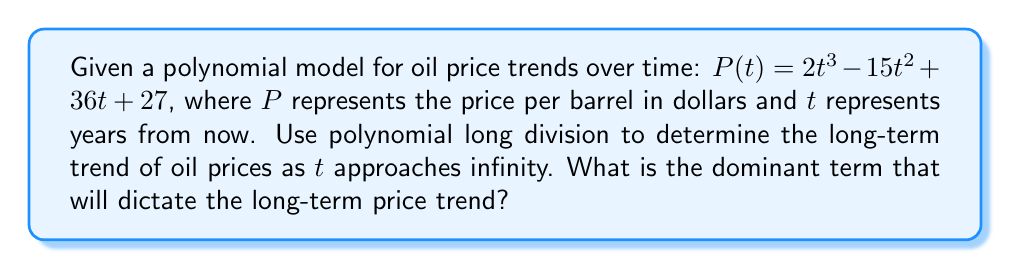What is the answer to this math problem? To determine the long-term trend of oil prices as $t$ approaches infinity, we need to perform polynomial long division of $P(t)$ by $t$. This will give us a quotient that represents the trend as $t$ becomes very large, and a remainder that becomes negligible in comparison.

Step 1: Set up the polynomial long division
$$\frac{2t^3 - 15t^2 + 36t + 27}{t}$$

Step 2: Divide $2t^3$ by $t$
Quotient: $2t^2$
Multiply: $2t^2 \cdot t = 2t^3$
Subtract: $2t^3 - 2t^3 = 0$

Step 3: Bring down $-15t^2$
Divide $-15t^2$ by $t$
Quotient: $-15t$
Multiply: $-15t \cdot t = -15t^2$
Subtract: $-15t^2 - (-15t^2) = 0$

Step 4: Bring down $36t$
Divide $36t$ by $t$
Quotient: $36$
Multiply: $36 \cdot t = 36t$
Subtract: $36t - 36t = 0$

Step 5: Bring down $27$
$27$ cannot be divided by $t$, so it becomes the remainder

The final result of the division is:
$$2t^2 - 15t + 36 + \frac{27}{t}$$

As $t$ approaches infinity, the term $\frac{27}{t}$ approaches zero, becoming negligible.

Therefore, the dominant term that will dictate the long-term price trend is the highest degree term in the quotient: $2t^2$.
Answer: $2t^2$ 